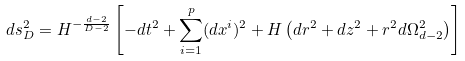Convert formula to latex. <formula><loc_0><loc_0><loc_500><loc_500>d s _ { D } ^ { 2 } = H ^ { - \frac { d - 2 } { D - 2 } } \left [ - d t ^ { 2 } + \sum _ { i = 1 } ^ { p } ( d x ^ { i } ) ^ { 2 } + H \left ( d r ^ { 2 } + d z ^ { 2 } + r ^ { 2 } d \Omega _ { d - 2 } ^ { 2 } \right ) \right ]</formula> 